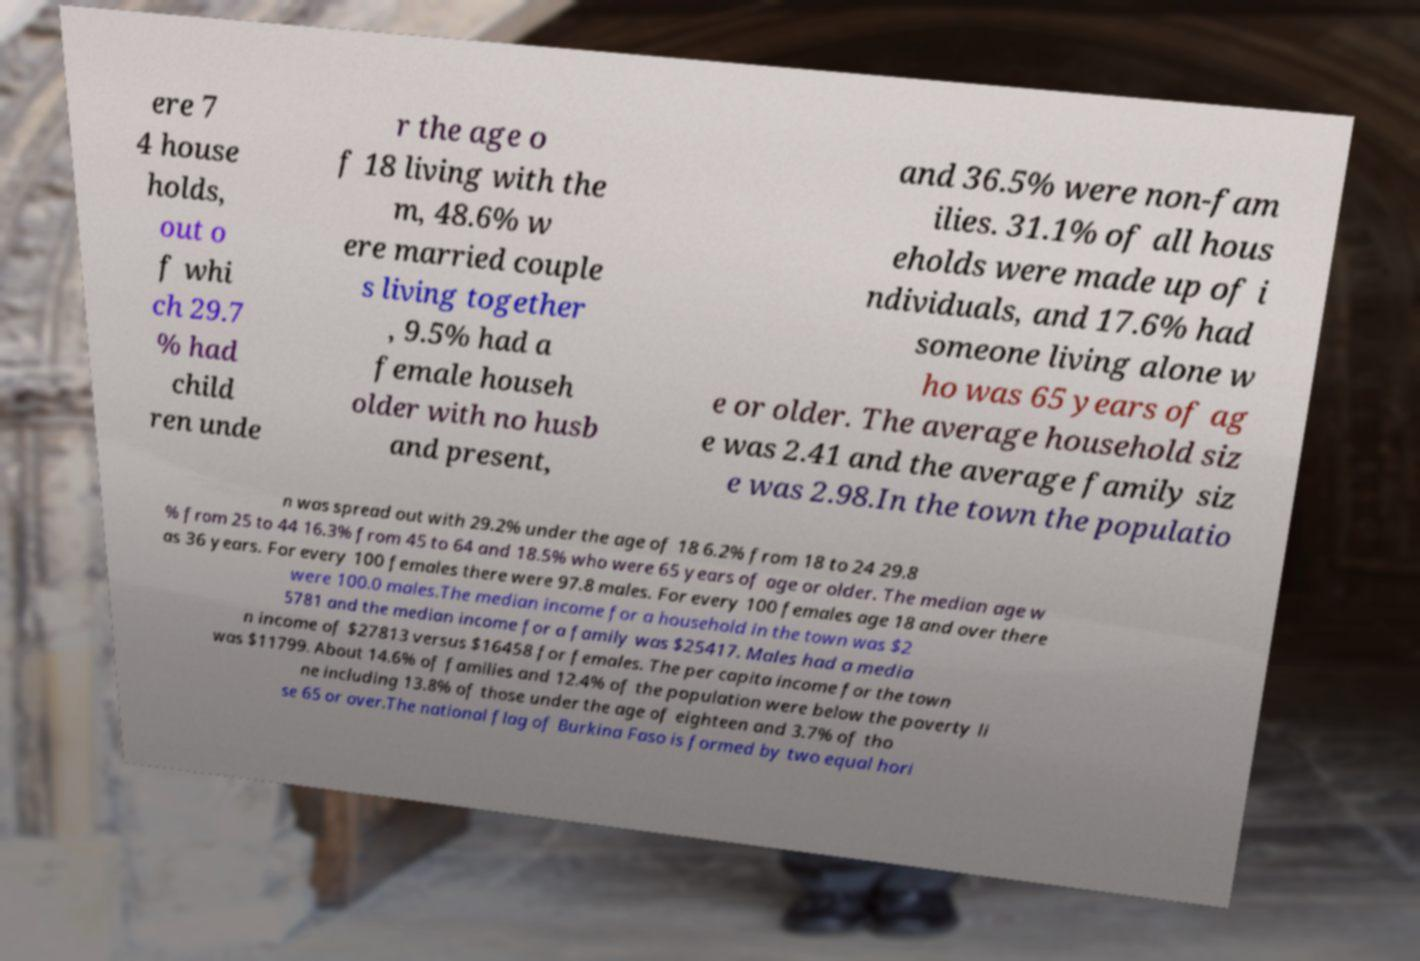What messages or text are displayed in this image? I need them in a readable, typed format. ere 7 4 house holds, out o f whi ch 29.7 % had child ren unde r the age o f 18 living with the m, 48.6% w ere married couple s living together , 9.5% had a female househ older with no husb and present, and 36.5% were non-fam ilies. 31.1% of all hous eholds were made up of i ndividuals, and 17.6% had someone living alone w ho was 65 years of ag e or older. The average household siz e was 2.41 and the average family siz e was 2.98.In the town the populatio n was spread out with 29.2% under the age of 18 6.2% from 18 to 24 29.8 % from 25 to 44 16.3% from 45 to 64 and 18.5% who were 65 years of age or older. The median age w as 36 years. For every 100 females there were 97.8 males. For every 100 females age 18 and over there were 100.0 males.The median income for a household in the town was $2 5781 and the median income for a family was $25417. Males had a media n income of $27813 versus $16458 for females. The per capita income for the town was $11799. About 14.6% of families and 12.4% of the population were below the poverty li ne including 13.8% of those under the age of eighteen and 3.7% of tho se 65 or over.The national flag of Burkina Faso is formed by two equal hori 